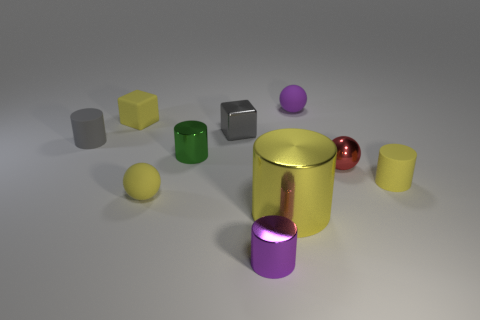Does the tiny sphere that is to the left of the large metal cylinder have the same color as the large shiny cylinder?
Provide a short and direct response. Yes. What number of other objects are there of the same color as the big object?
Your response must be concise. 3. What number of purple objects are either small shiny cylinders or matte balls?
Provide a succinct answer. 2. There is a big metallic object; is it the same shape as the yellow thing that is behind the gray metal object?
Give a very brief answer. No. There is a small red metallic object; what shape is it?
Your answer should be very brief. Sphere. What is the material of the yellow sphere that is the same size as the green cylinder?
Provide a succinct answer. Rubber. Is there anything else that is the same size as the yellow shiny cylinder?
Your response must be concise. No. What number of things are large green metal balls or yellow objects that are in front of the red metal object?
Offer a terse response. 3. There is a gray object that is the same material as the tiny yellow cube; what size is it?
Make the answer very short. Small. There is a purple object that is behind the object that is to the right of the red object; what is its shape?
Your answer should be very brief. Sphere. 